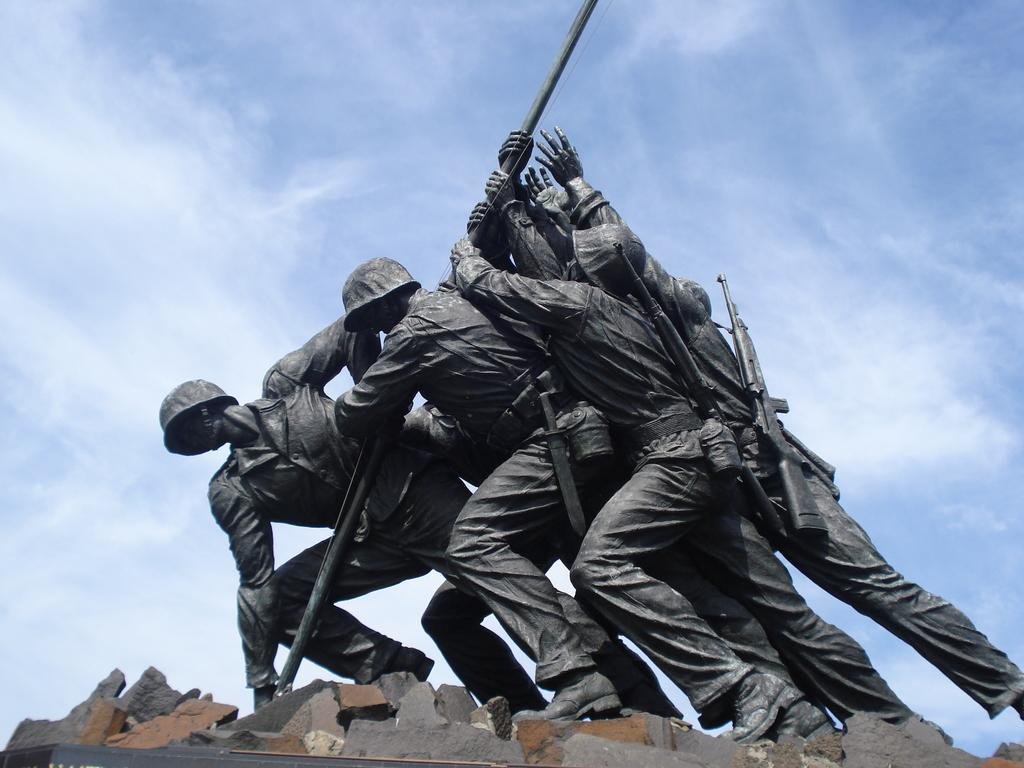What type of statues can be seen in the image? There are statues of human soldiers in the image. What color is the sky in the image? The sky is blue in the image. What musical instrument is being played by the statues in the image? There is no musical instrument being played by the statues in the image; they are statues and not capable of playing instruments. 